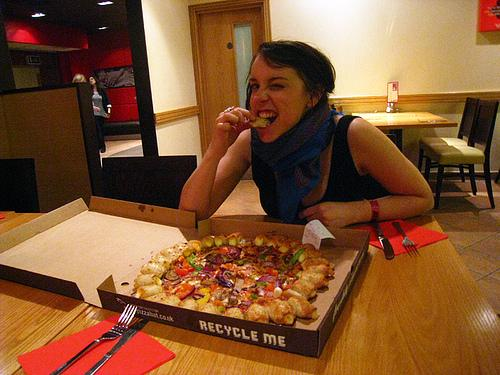Which item here can be turned into something else without eating it? Please explain your reasoning. pizza box. The writing on the side of the box indicates that it can be recycled and thus turned into another product in time. 